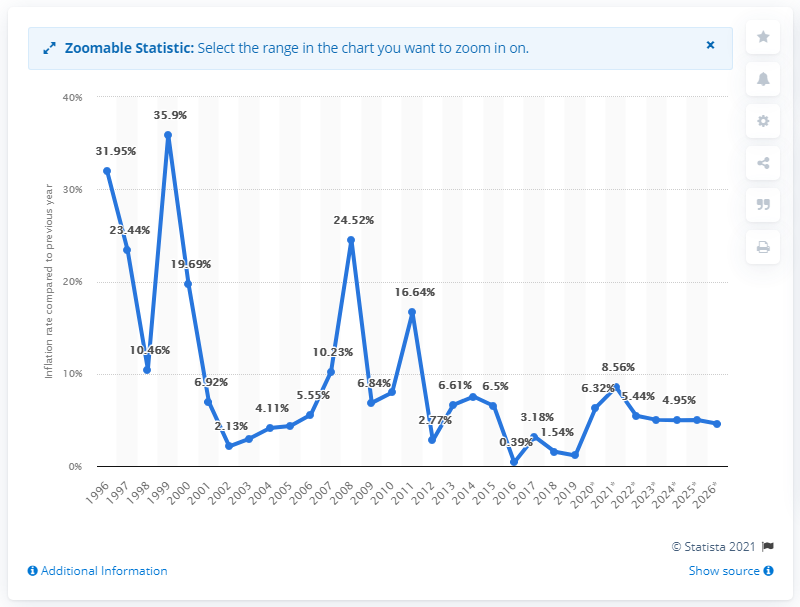Mention a couple of crucial points in this snapshot. The average inflation rate in the Kyrgyz Republic was in 1996. In 2019, the inflation rate in the Kyrgyz Republic was 1.14%. 